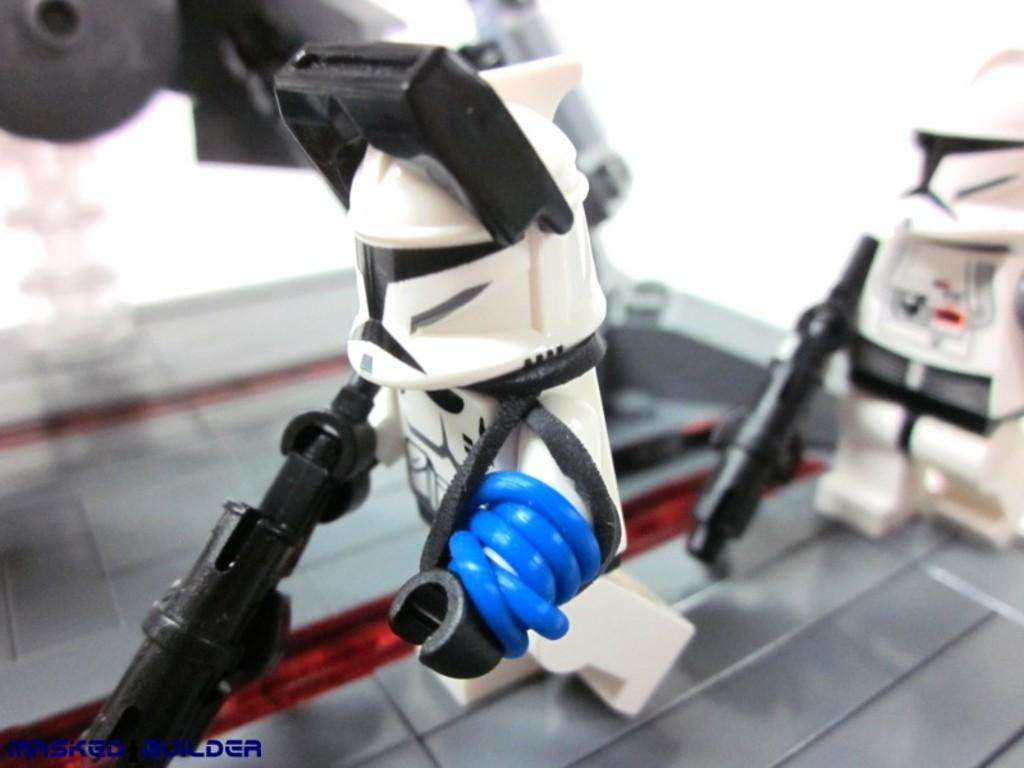What is the main subject in the middle of the image? There is a small robot toy in the middle of the image. Can you describe the background of the image? There is another small robot in the background of the image. What is the background robot holding? The background robot is holding a gun. Where is the clock located in the image? There is no clock present in the image. What type of drawer can be seen in the image? There is no drawer present in the image. 